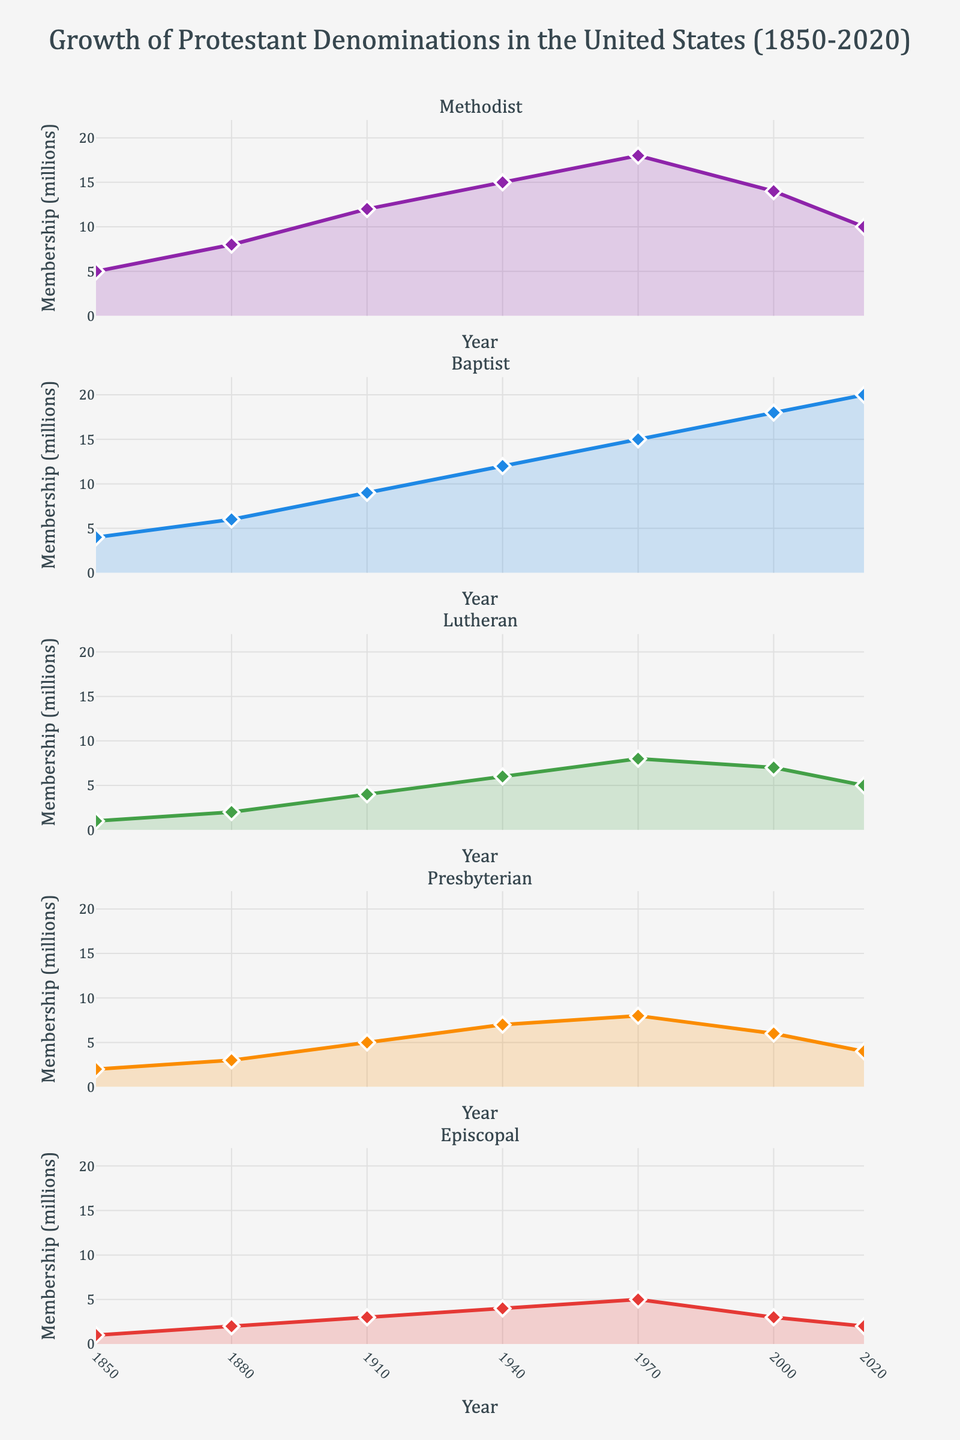What's the title of the figure? The title is prominently displayed at the top of the figure and it reads: "Growth of Protestant Denominations in the United States (1850-2020)"
Answer: Growth of Protestant Denominations in the United States (1850-2020) How many Protestant denominations are represented in the figure? There are five subplot titles, one for each Protestant denomination represented in the vertical subplots.
Answer: Five Which Protestant denomination had the highest membership in 2020? In the subplot for 2020, the data point for the Baptist denomination is the highest compared to the other denominations.
Answer: Baptist In which year did the Methodist denomination reach its peak membership? By observing the Methodist subplot, the peak membership was reached in the year 1970 where the line marker is the highest.
Answer: 1970 What was the membership of the Episcopal denomination in 2000? By looking at the Episcopal subplot, the marker for the year 2000 indicates a value of 3 million.
Answer: 3 million Which two denominations showed a declining trend after 1970? Observing the subplots for the Methodist and Presbyterian denominations, both show peak values around 1970 and exhibit a declining trend afterward.
Answer: Methodist, Presbyterian Between which years did the Lutheran denomination experience its fastest growth? The Lutheran subplot indicates the steepest slope in the line between 1910 and 1940, which signifies the fastest growth period.
Answer: 1910-1940 What is the difference in membership between the Baptist and Lutheran denominations in 1940? From the subplots, the Baptist denomination had a membership of 12 million, and the Lutheran denomination had 6 million in 1940. The difference is 12 - 6 = 6 million.
Answer: 6 million Which denomination maintained a nearly constant membership between 1970 and 2020? From the subplots, the Episcopal denomination shows a relatively flat line between 1970 and 2020, indicating stable membership.
Answer: Episcopal What is the average membership of the Baptist denomination over the entire period shown? The membership values for the Baptist denomination are: 4, 6, 9, 12, 15, 18, 20. The average is (4 + 6 + 9 + 12 + 15 + 18 + 20) / 7 = 84 / 7 = 12 million.
Answer: 12 million 